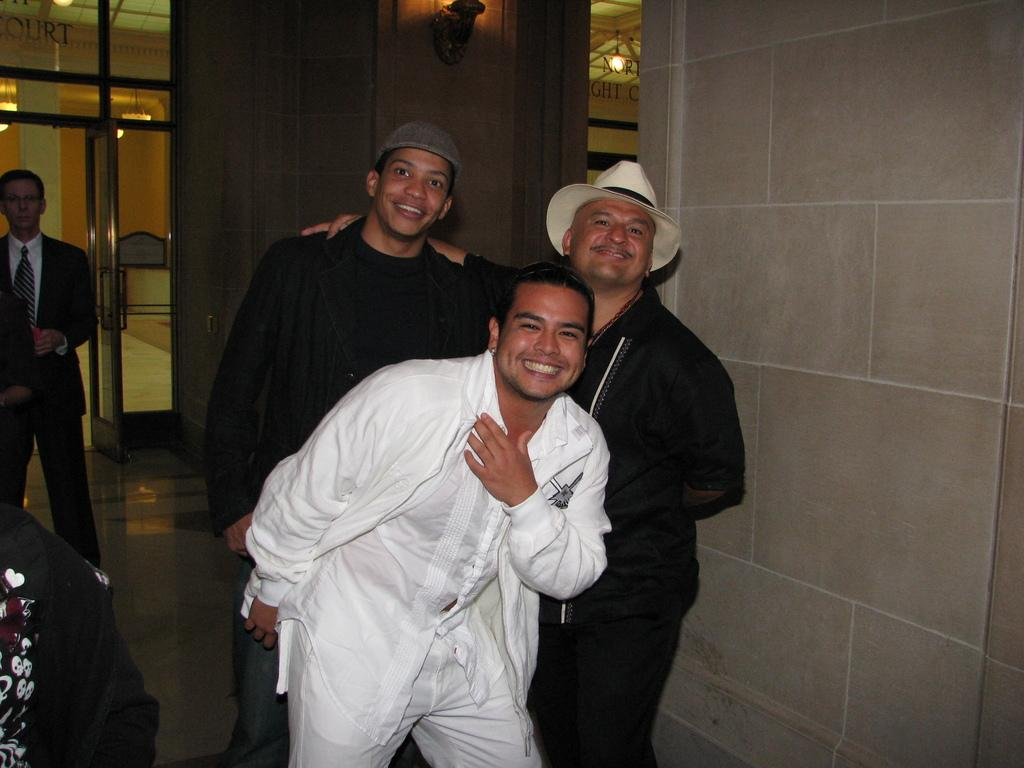How many men are standing in the image? There are three men standing in the image. What is the facial expression of the men? The men are smiling. What can be seen in the background of the image? In the background, there is a man wearing a blazer and a tie, as well as a wall and lights. What type of caption is written on the wall in the image? There is no caption visible on the wall in the image. How does the society depicted in the image function? The image does not depict a society, so it is not possible to determine how it functions. 